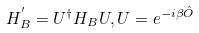<formula> <loc_0><loc_0><loc_500><loc_500>H _ { B } ^ { ^ { \prime } } = U ^ { \dagger } H _ { B } U , U = e ^ { - i \beta \hat { O } }</formula> 